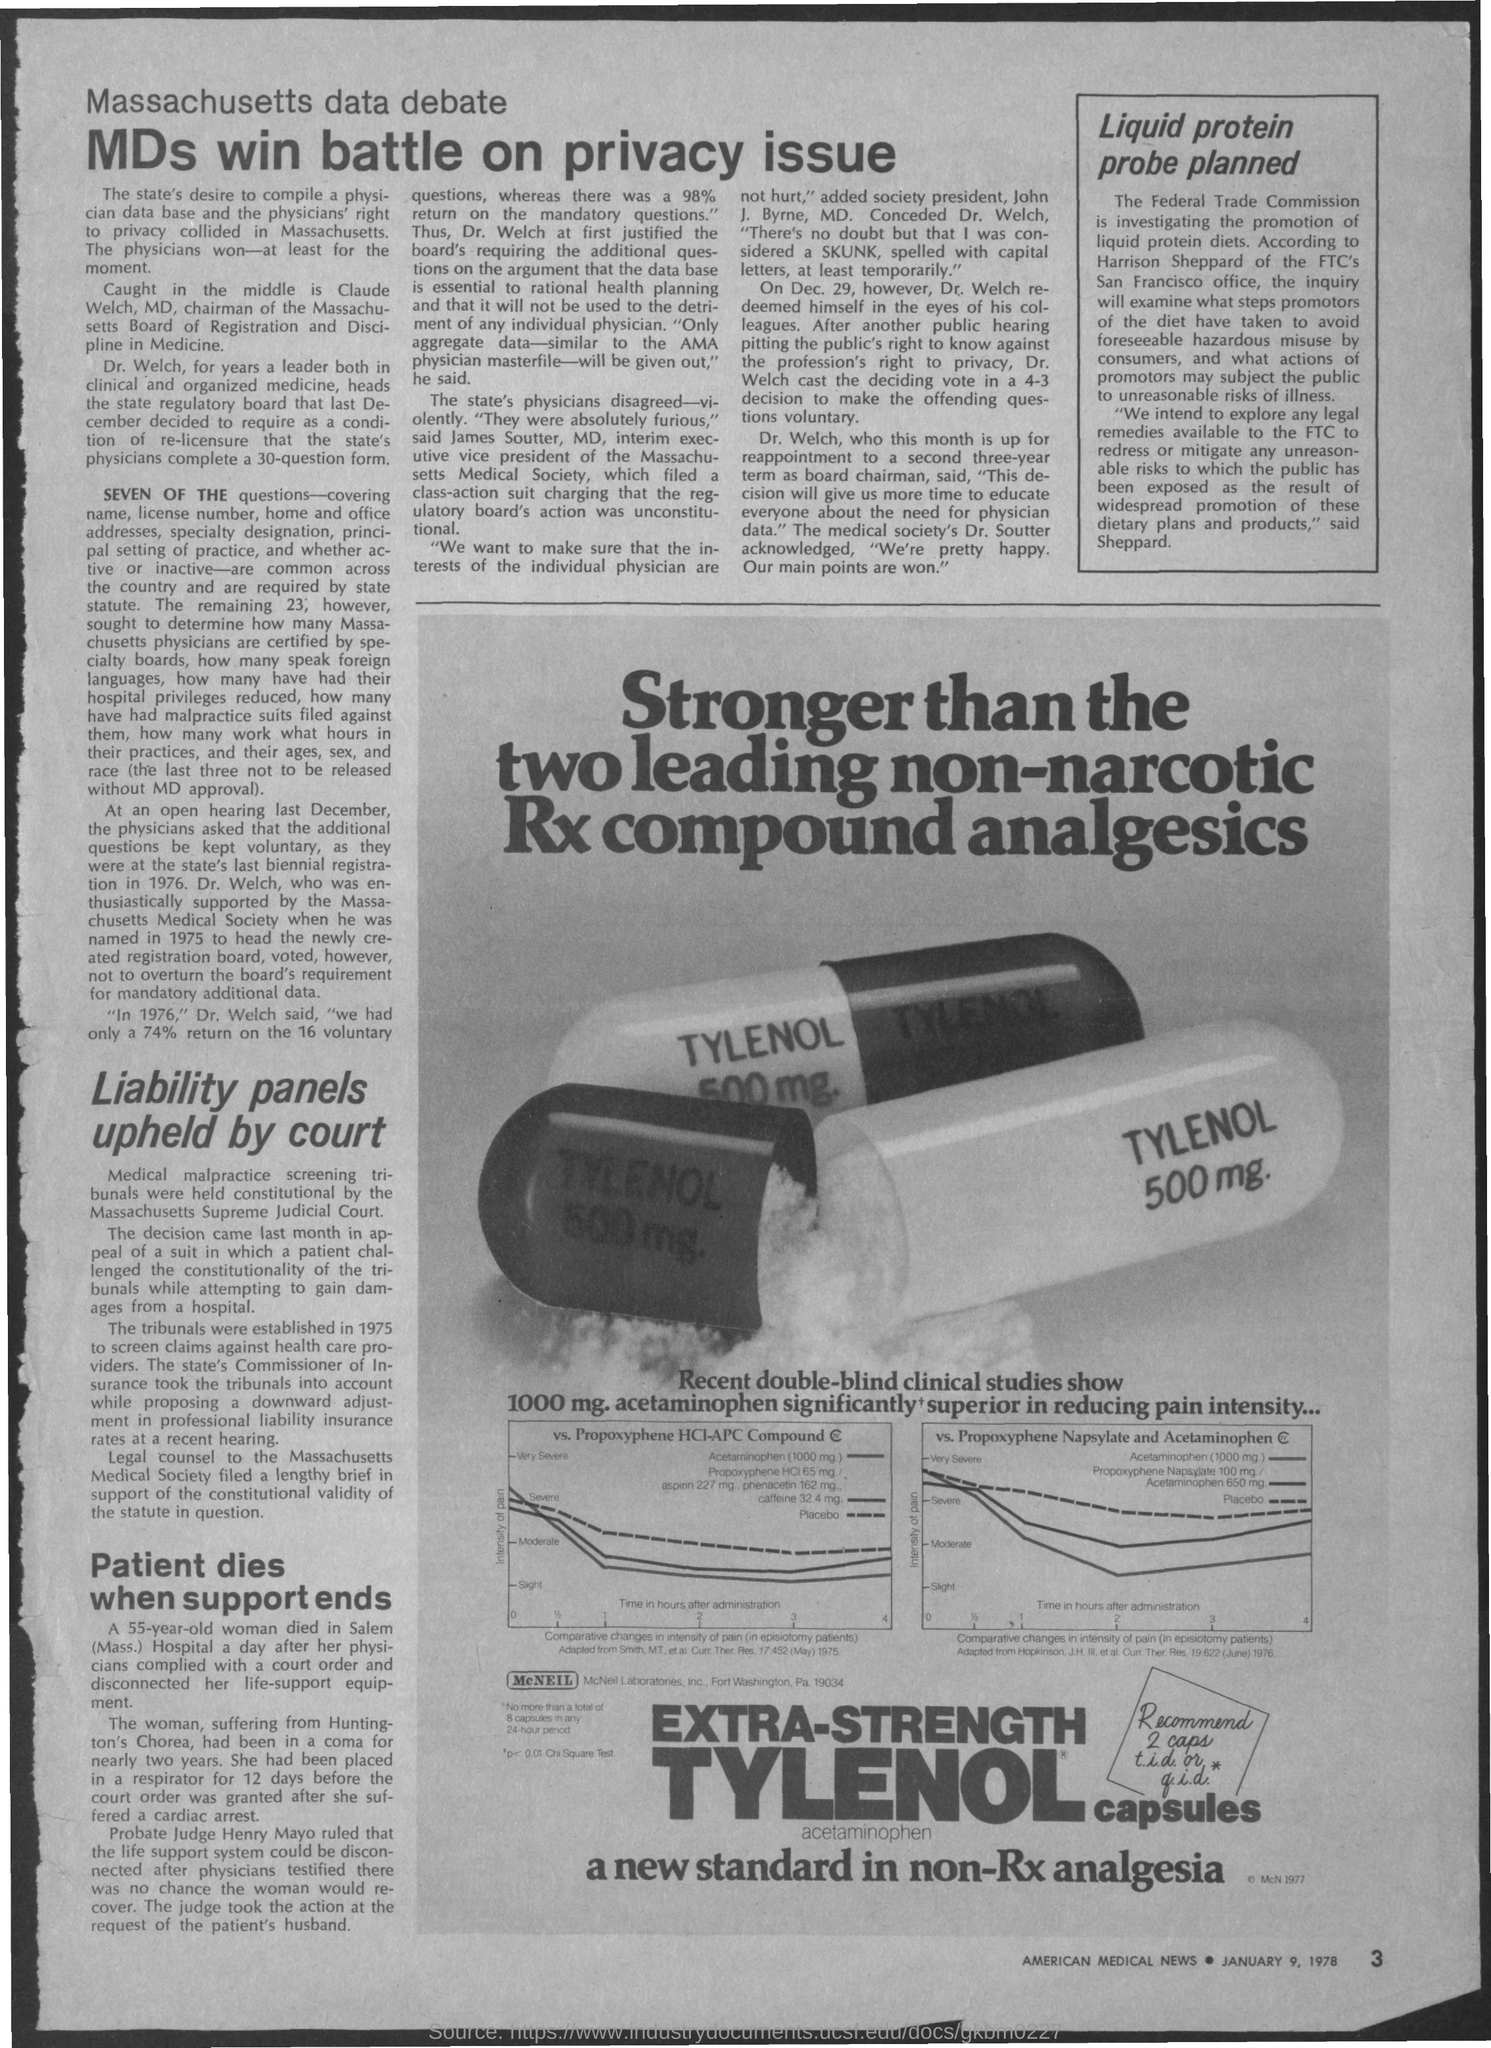Who wins the battle on privacy issue?
Offer a terse response. MDs. What is the date on the document?
Your answer should be compact. January 9, 1978. 